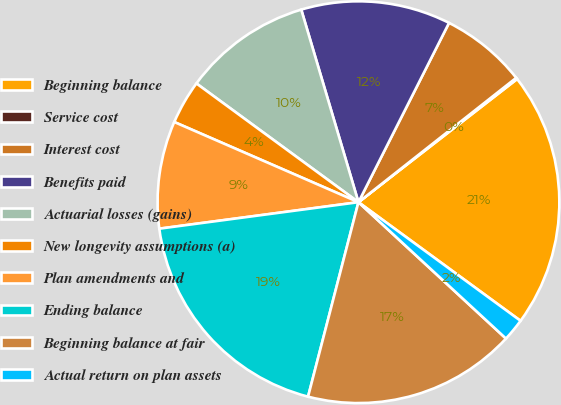Convert chart. <chart><loc_0><loc_0><loc_500><loc_500><pie_chart><fcel>Beginning balance<fcel>Service cost<fcel>Interest cost<fcel>Benefits paid<fcel>Actuarial losses (gains)<fcel>New longevity assumptions (a)<fcel>Plan amendments and<fcel>Ending balance<fcel>Beginning balance at fair<fcel>Actual return on plan assets<nl><fcel>20.56%<fcel>0.12%<fcel>6.93%<fcel>12.04%<fcel>10.34%<fcel>3.53%<fcel>8.64%<fcel>18.86%<fcel>17.16%<fcel>1.82%<nl></chart> 